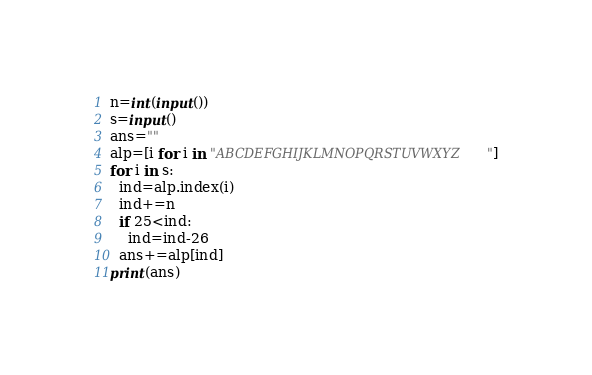<code> <loc_0><loc_0><loc_500><loc_500><_Python_>n=int(input())
s=input()
ans=""
alp=[i for i in "ABCDEFGHIJKLMNOPQRSTUVWXYZ"]
for i in s:
  ind=alp.index(i)
  ind+=n
  if 25<ind:
    ind=ind-26
  ans+=alp[ind]
print(ans)</code> 